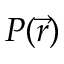Convert formula to latex. <formula><loc_0><loc_0><loc_500><loc_500>P ( \vec { r } )</formula> 